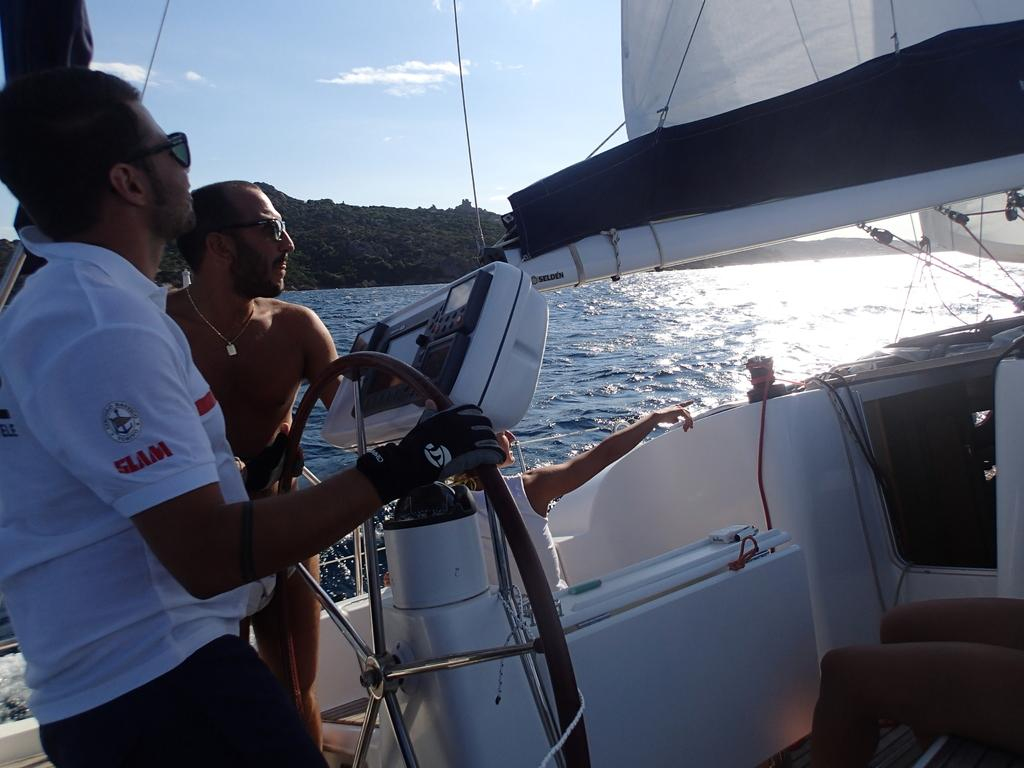Who or what is present in the image? There are people in the image. Where are the people located? The people are on a ship. What can be seen in the background of the image? There is water and the sky visible in the background of the image. What type of pencil can be seen being used by the people in the image? There is no pencil present in the image; the people are on a ship, and no pencil-related activity is depicted. 